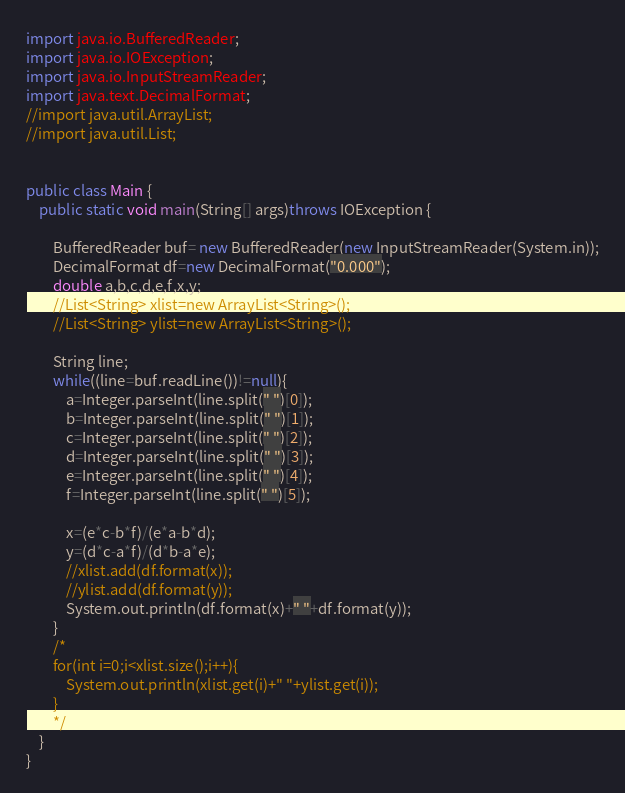<code> <loc_0><loc_0><loc_500><loc_500><_Java_>import java.io.BufferedReader;
import java.io.IOException;
import java.io.InputStreamReader;
import java.text.DecimalFormat;
//import java.util.ArrayList;
//import java.util.List;


public class Main {
	public static void main(String[] args)throws IOException {
		
		BufferedReader buf= new BufferedReader(new InputStreamReader(System.in));
		DecimalFormat df=new DecimalFormat("0.000");
		double a,b,c,d,e,f,x,y;
		//List<String> xlist=new ArrayList<String>();
		//List<String> ylist=new ArrayList<String>();
		
		String line;
		while((line=buf.readLine())!=null){
			a=Integer.parseInt(line.split(" ")[0]);
			b=Integer.parseInt(line.split(" ")[1]);
			c=Integer.parseInt(line.split(" ")[2]);
			d=Integer.parseInt(line.split(" ")[3]);
			e=Integer.parseInt(line.split(" ")[4]);
			f=Integer.parseInt(line.split(" ")[5]);
			
			x=(e*c-b*f)/(e*a-b*d);
			y=(d*c-a*f)/(d*b-a*e);
			//xlist.add(df.format(x));
			//ylist.add(df.format(y));
			System.out.println(df.format(x)+" "+df.format(y));
		}
		/*
		for(int i=0;i<xlist.size();i++){
			System.out.println(xlist.get(i)+" "+ylist.get(i));
		}
		*/
	}
}</code> 